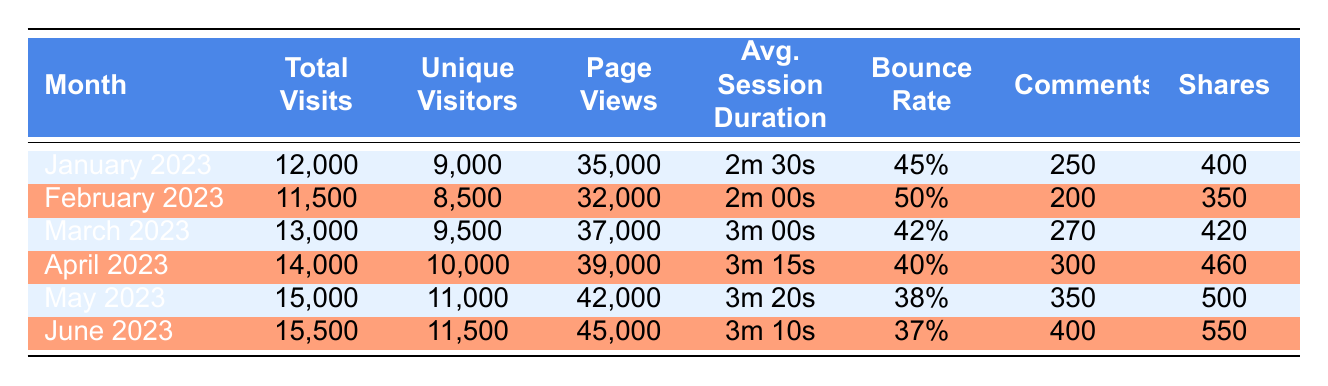What was the total number of visits in June 2023? Referring to the table, the value in the "Total Visits" column for June 2023 is 15,500.
Answer: 15,500 Which month had the highest unique visitors? By comparing the "Unique Visitors" column values, June 2023 has 11,500, which is the highest among all months listed.
Answer: June 2023 What is the average bounce rate for the first three months (January, February, March 2023)? The bounce rates for January, February, and March are 45%, 50%, and 42%, respectively. To calculate the average, we add them up (45 + 50 + 42) = 137 and divide by 3, yielding an average bounce rate of approximately 45.67%.
Answer: 45.67% Did the total visits decrease from January to February 2023? The total visits for January 2023 are 12,000 and for February 2023 are 11,500. Since 11,500 is less than 12,000, the total visits did indeed decrease.
Answer: Yes What was the percentage increase in shares from February to April 2023? The shares in February 2023 were 350, and in April 2023, they were 460. The difference is 460 - 350 = 110. To find the percentage increase, divide the difference by the original number (350) and multiply by 100. (110/350) * 100 = 31.43%.
Answer: 31.43% Which month had the longest average session duration, and what was that duration? By examining the "Avg. Session Duration" column, April 2023 shows the longest duration, recorded as 3m 15s.
Answer: April 2023, 3m 15s What was the total number of comments in the first half of 2023? The total comments are: January (250), February (200), March (270), April (300), May (350), and June (400). Adding these gives 250 + 200 + 270 + 300 + 350 + 400 = 1,770.
Answer: 1,770 Is the average session duration longer in May compared to January 2023? The average session duration for May is 3m 20s, while for January it is 2m 30s. Since 3m 20s is longer than 2m 30s, the answer is affirmative.
Answer: Yes What was the total increase in page views from January to June 2023? January's page views were 35,000 and June's were 45,000. The increase is 45,000 - 35,000 = 10,000.
Answer: 10,000 